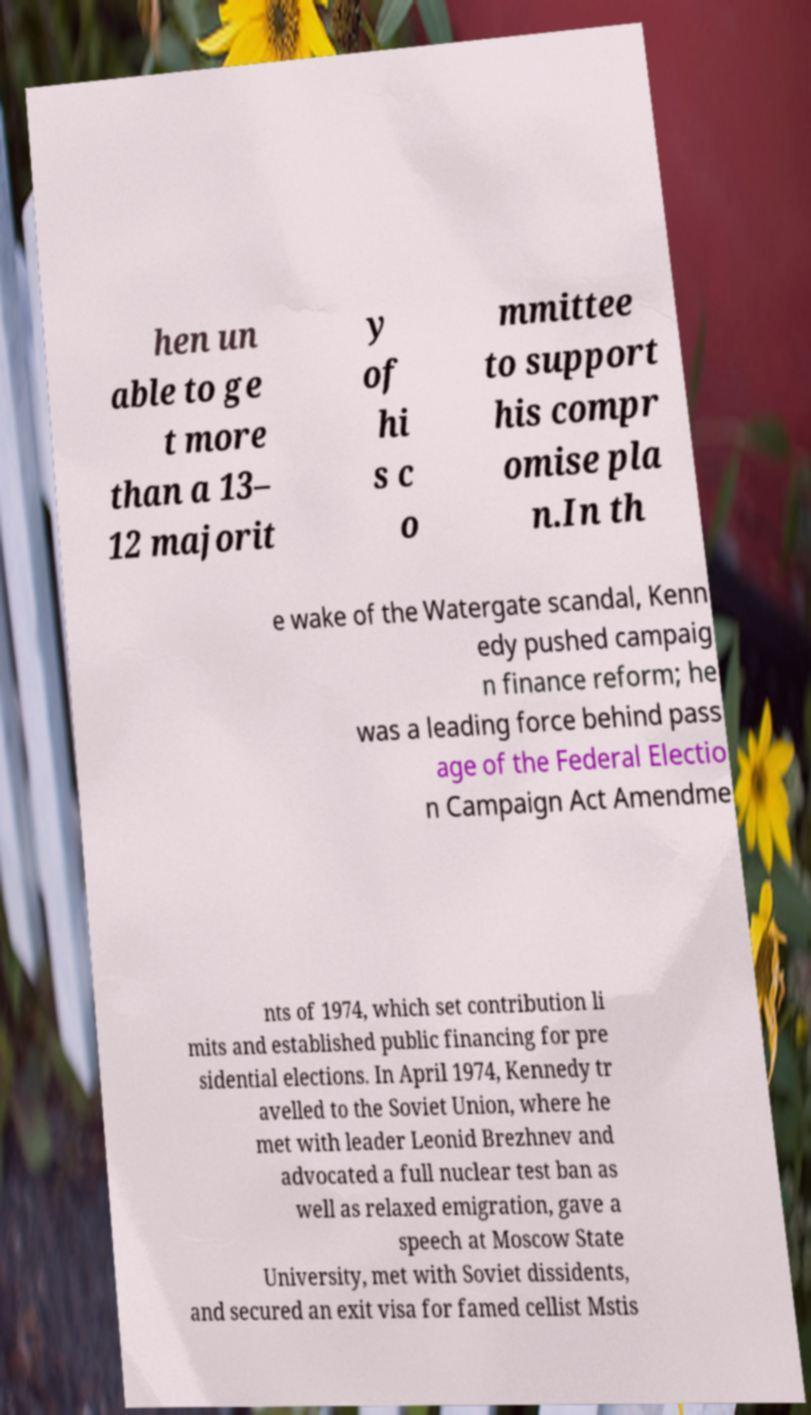For documentation purposes, I need the text within this image transcribed. Could you provide that? hen un able to ge t more than a 13– 12 majorit y of hi s c o mmittee to support his compr omise pla n.In th e wake of the Watergate scandal, Kenn edy pushed campaig n finance reform; he was a leading force behind pass age of the Federal Electio n Campaign Act Amendme nts of 1974, which set contribution li mits and established public financing for pre sidential elections. In April 1974, Kennedy tr avelled to the Soviet Union, where he met with leader Leonid Brezhnev and advocated a full nuclear test ban as well as relaxed emigration, gave a speech at Moscow State University, met with Soviet dissidents, and secured an exit visa for famed cellist Mstis 